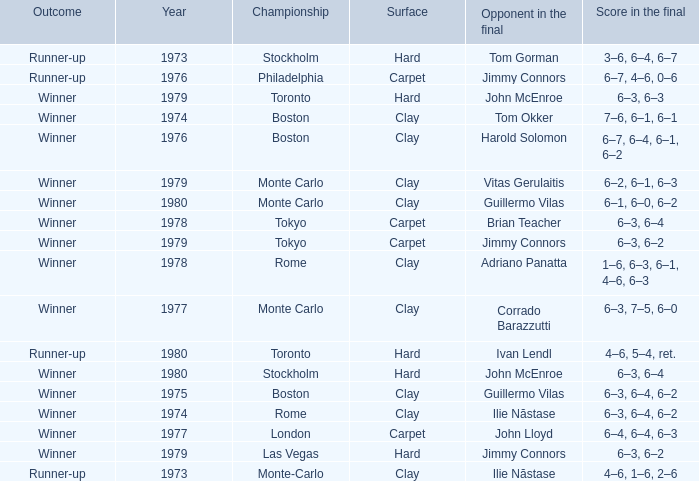Name the surface for philadelphia Carpet. 